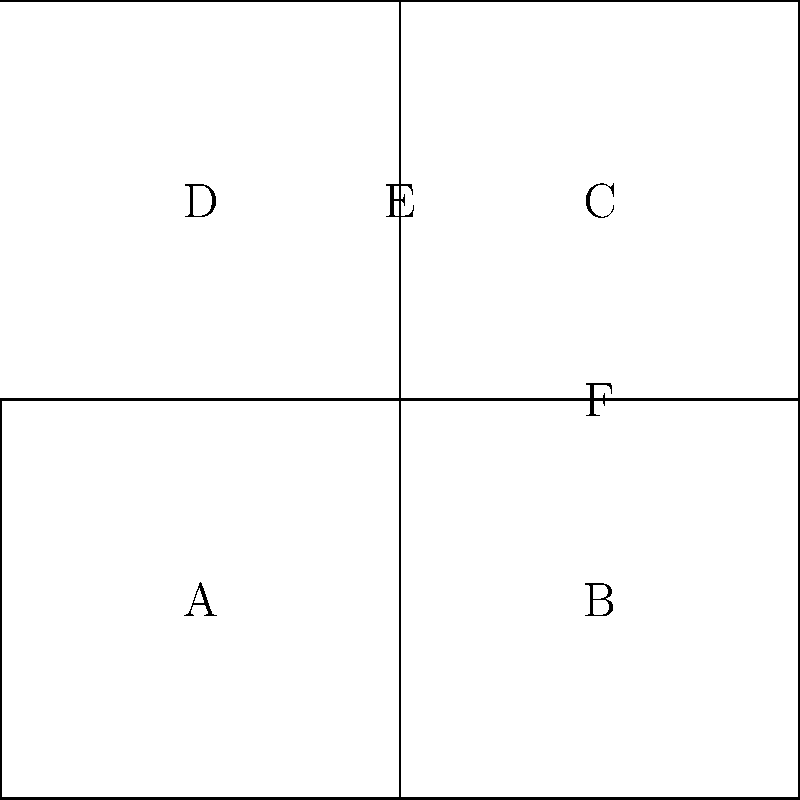На рисунке показана развертка куба. Какие грани будут противоположными друг другу после сборки куба? Давайте разберем это шаг за шагом:

1) Сначала представим, как куб складывается. Грани A, B, C, и D образуют боковые стороны куба.

2) Грань E станет верхней гранью куба, а грань F - нижней.

3) Теперь подумаем о противоположных гранях:
   - Если E - верхняя грань, то F будет ей противоположна (нижняя грань).
   - Грань A будет противоположна грани C, так как они находятся на противоположных сторонах развертки.
   - Грань B будет противоположна грани D по той же причине.

4) Таким образом, пары противоположных граней:
   - E и F
   - A и C
   - B и D

Это задание помогает развивать пространственное мышление, что важно не только в биологии, но и во многих других науках.
Answer: E-F, A-C, B-D 